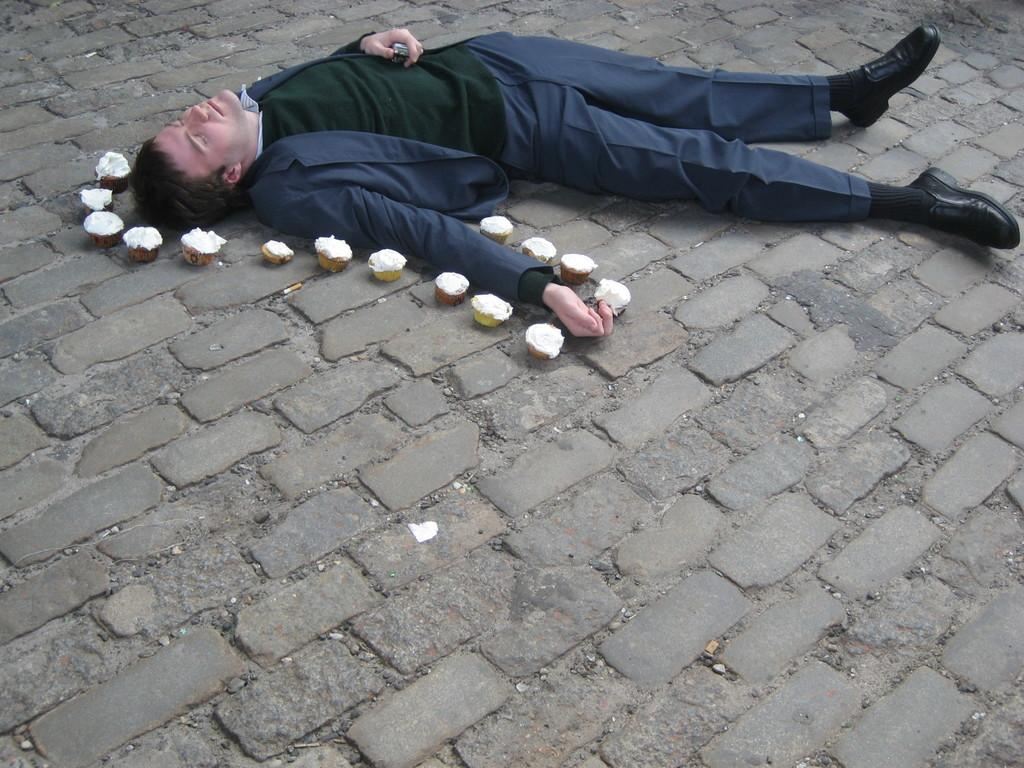What is the main subject of the image? There is a person in the image. What is the person wearing? The person is wearing a suit. What is the person's position in the image? The person is lying on the floor. What else can be seen on the floor in the image? There are cups on the floor. What type of footwear is the person wearing? The person is wearing shoes. How many dolls are present in the aftermath of the spider's attack in the image? There are no dolls, aftermath, or spiders present in the image. 